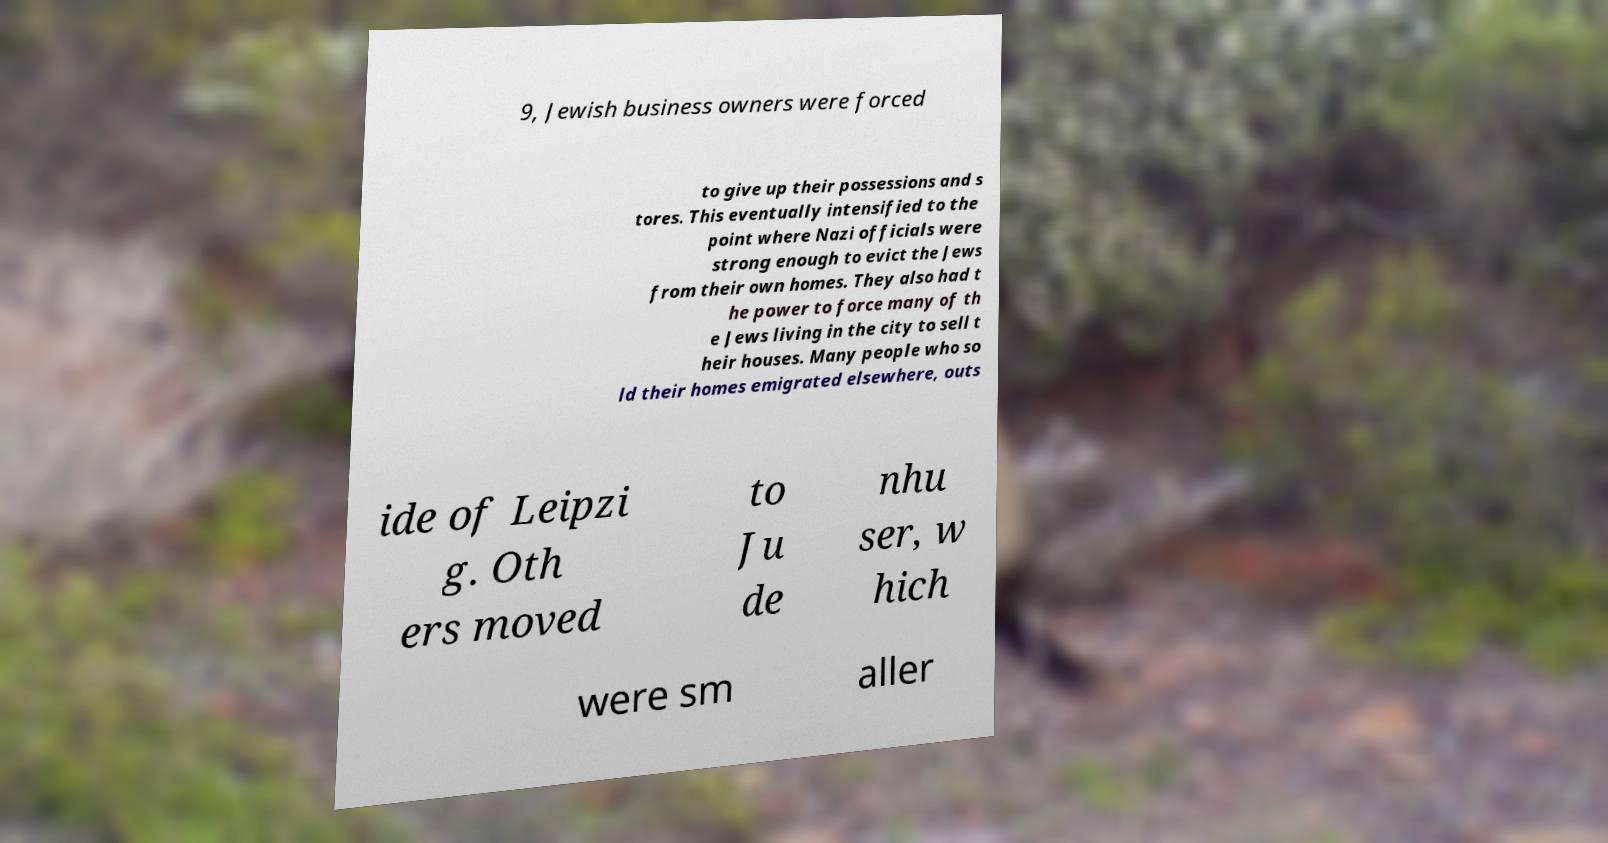Can you accurately transcribe the text from the provided image for me? 9, Jewish business owners were forced to give up their possessions and s tores. This eventually intensified to the point where Nazi officials were strong enough to evict the Jews from their own homes. They also had t he power to force many of th e Jews living in the city to sell t heir houses. Many people who so ld their homes emigrated elsewhere, outs ide of Leipzi g. Oth ers moved to Ju de nhu ser, w hich were sm aller 